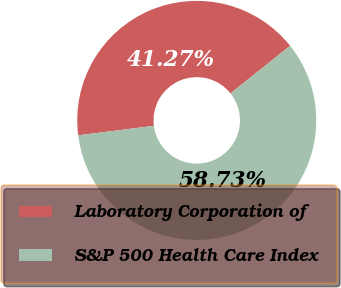<chart> <loc_0><loc_0><loc_500><loc_500><pie_chart><fcel>Laboratory Corporation of<fcel>S&P 500 Health Care Index<nl><fcel>41.27%<fcel>58.73%<nl></chart> 